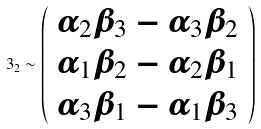Convert formula to latex. <formula><loc_0><loc_0><loc_500><loc_500>3 _ { 2 } \sim \left ( \begin{array} { c } \alpha _ { 2 } \beta _ { 3 } - \alpha _ { 3 } \beta _ { 2 } \\ \alpha _ { 1 } \beta _ { 2 } - \alpha _ { 2 } \beta _ { 1 } \\ \alpha _ { 3 } \beta _ { 1 } - \alpha _ { 1 } \beta _ { 3 } \end{array} \right )</formula> 